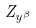<formula> <loc_0><loc_0><loc_500><loc_500>Z _ { y ^ { \beta } }</formula> 